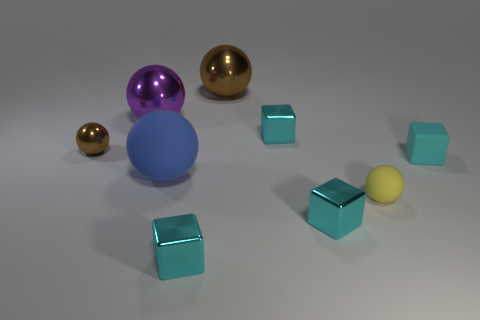How many cyan cubes must be subtracted to get 1 cyan cubes? 3 Subtract all cyan cubes. How many brown balls are left? 2 Subtract all tiny cyan shiny blocks. How many blocks are left? 1 Add 1 tiny cubes. How many objects exist? 10 Subtract all brown spheres. How many spheres are left? 3 Subtract 1 cubes. How many cubes are left? 3 Subtract all spheres. How many objects are left? 4 Subtract all gray cubes. Subtract all blue cylinders. How many cubes are left? 4 Add 1 tiny brown metallic spheres. How many tiny brown metallic spheres exist? 2 Subtract 0 brown cubes. How many objects are left? 9 